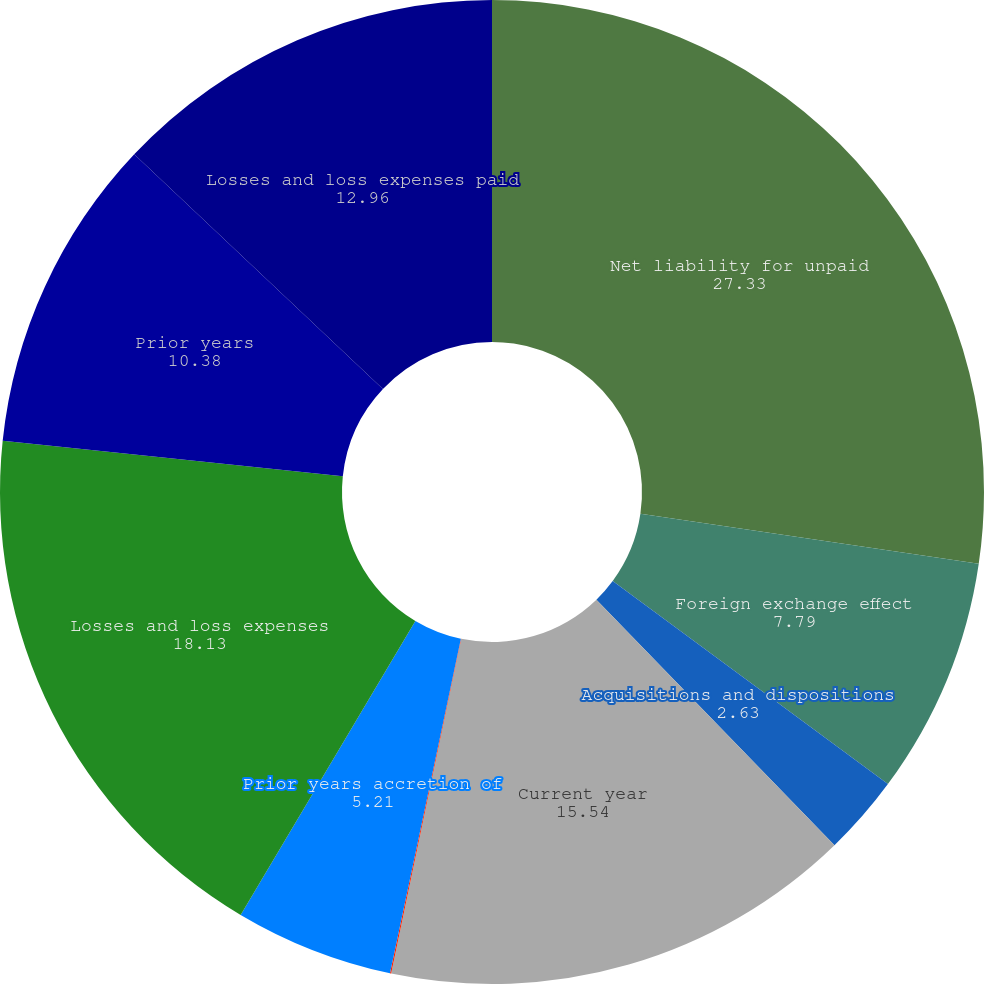<chart> <loc_0><loc_0><loc_500><loc_500><pie_chart><fcel>Net liability for unpaid<fcel>Foreign exchange effect<fcel>Acquisitions and dispositions<fcel>Current year<fcel>Prior years other than<fcel>Prior years accretion of<fcel>Losses and loss expenses<fcel>Prior years<fcel>Losses and loss expenses paid<nl><fcel>27.33%<fcel>7.79%<fcel>2.63%<fcel>15.54%<fcel>0.04%<fcel>5.21%<fcel>18.13%<fcel>10.38%<fcel>12.96%<nl></chart> 